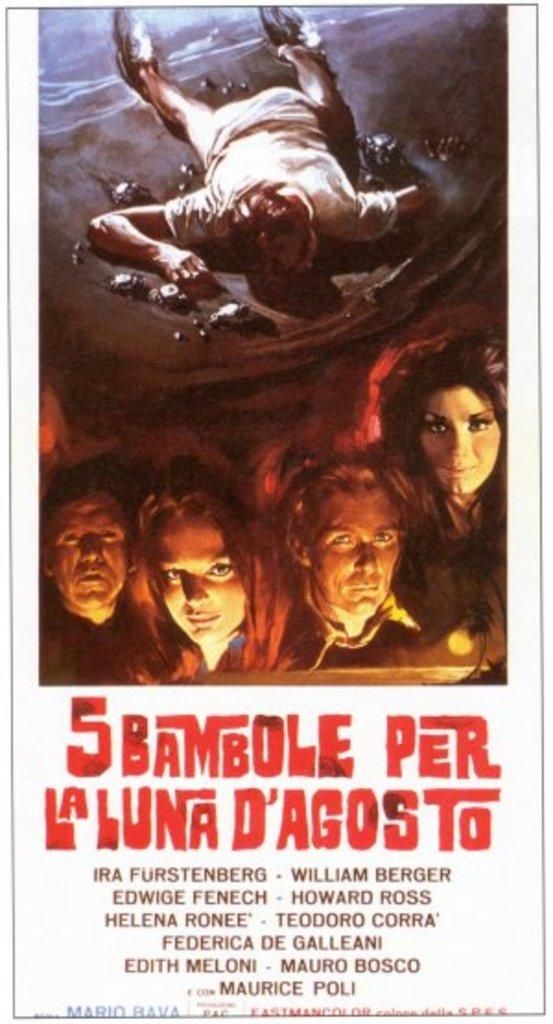<image>
Share a concise interpretation of the image provided. A movie poster has the number 5 at the beginning of the title. 